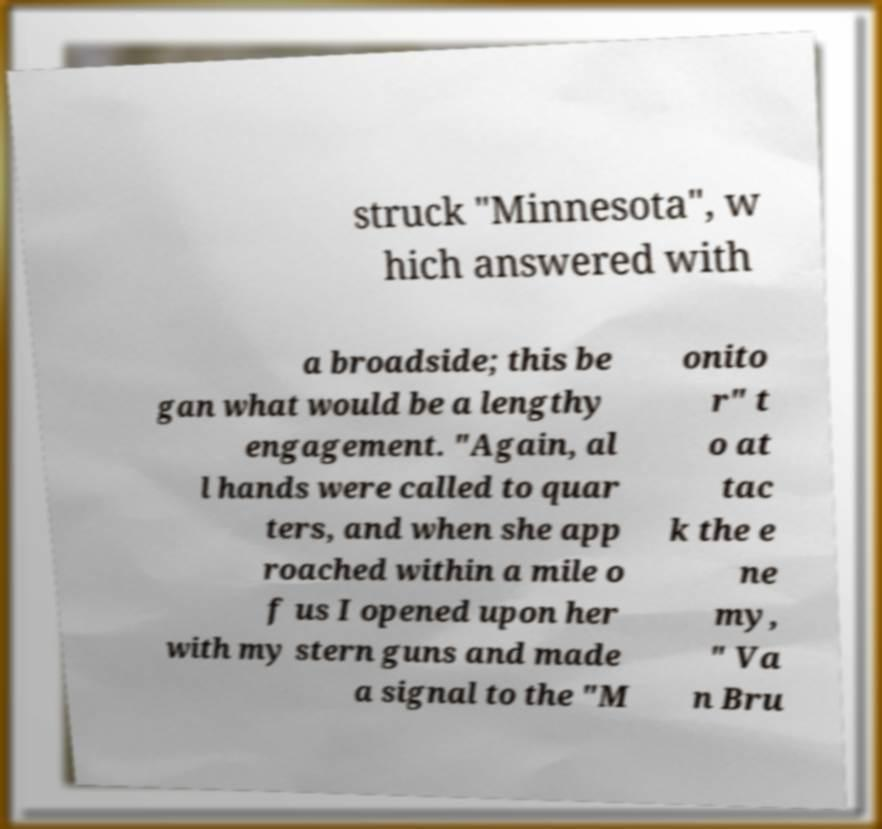For documentation purposes, I need the text within this image transcribed. Could you provide that? struck "Minnesota", w hich answered with a broadside; this be gan what would be a lengthy engagement. "Again, al l hands were called to quar ters, and when she app roached within a mile o f us I opened upon her with my stern guns and made a signal to the "M onito r" t o at tac k the e ne my, " Va n Bru 